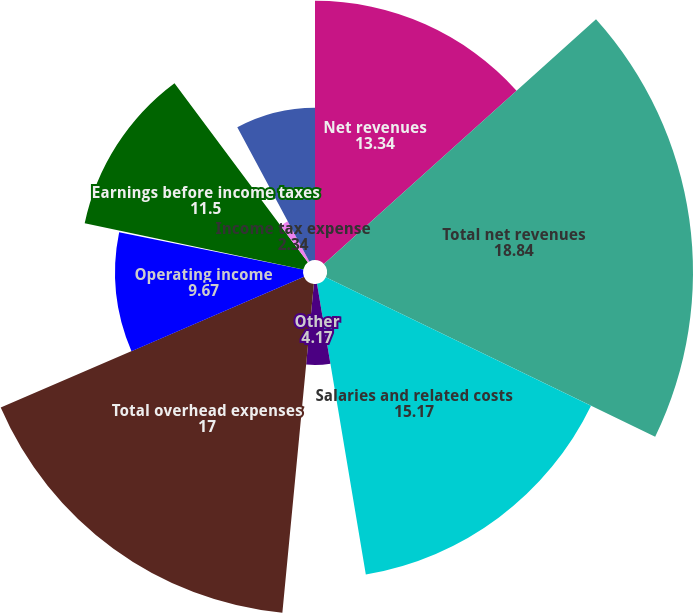Convert chart. <chart><loc_0><loc_0><loc_500><loc_500><pie_chart><fcel>Net revenues<fcel>Total net revenues<fcel>Salaries and related costs<fcel>Other<fcel>Total overhead expenses<fcel>Operating income<fcel>Other income net<fcel>Earnings before income taxes<fcel>Income tax expense<fcel>Net earnings<nl><fcel>13.34%<fcel>18.84%<fcel>15.17%<fcel>4.17%<fcel>17.0%<fcel>9.67%<fcel>0.13%<fcel>11.5%<fcel>2.34%<fcel>7.84%<nl></chart> 